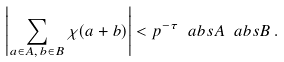Convert formula to latex. <formula><loc_0><loc_0><loc_500><loc_500>\left | \sum _ { a \in A , \, b \in B } \chi ( a + b ) \right | < p ^ { - \tau } \ a b s { A } \ a b s { B } \, .</formula> 